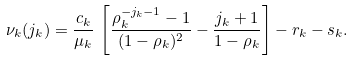<formula> <loc_0><loc_0><loc_500><loc_500>\nu _ { k } ( j _ { k } ) = \frac { c _ { k } } { \mu _ { k } } \, \left [ \frac { \rho _ { k } ^ { - j _ { k } - 1 } - 1 } { ( 1 - \rho _ { k } ) ^ { 2 } } - \frac { j _ { k } + 1 } { 1 - \rho _ { k } } \right ] - r _ { k } - s _ { k } .</formula> 